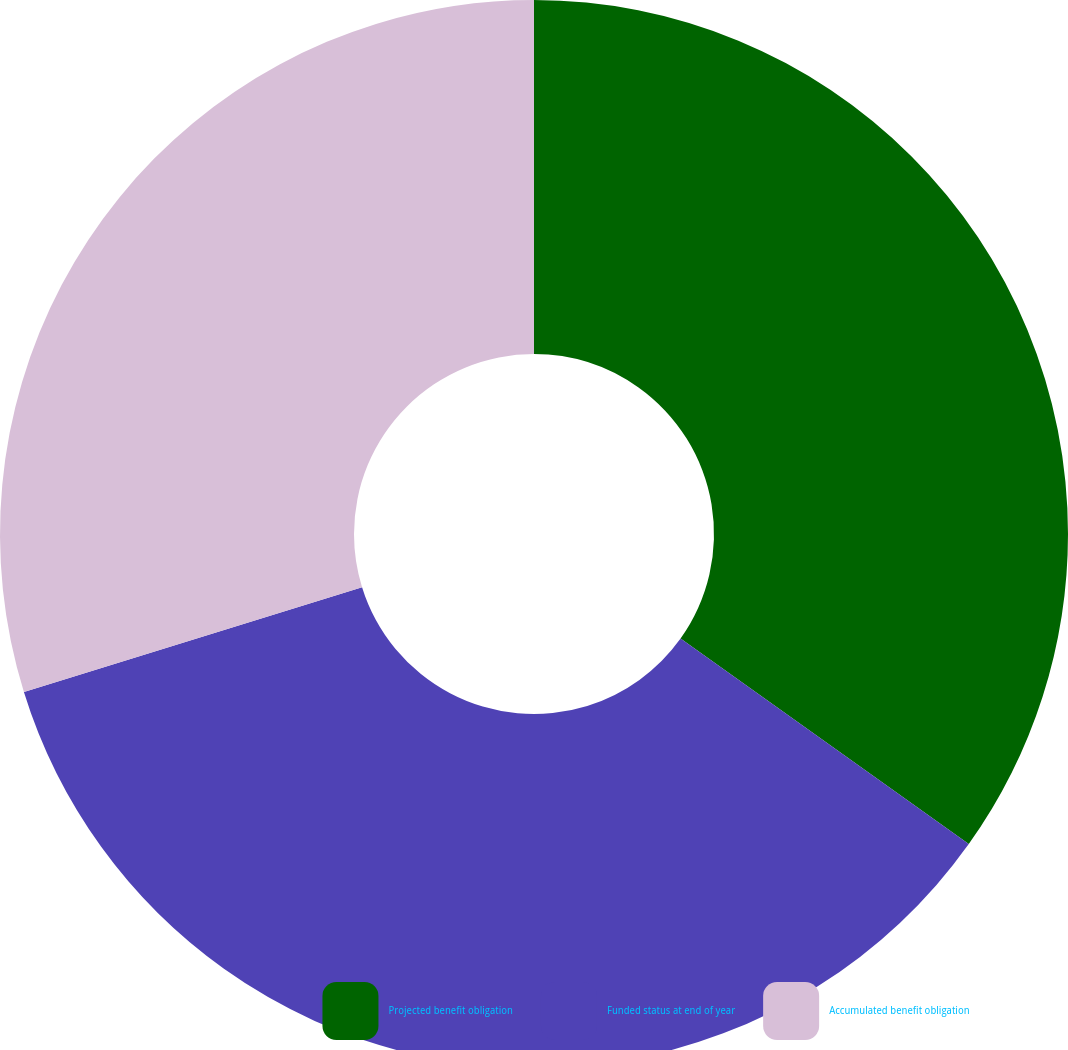Convert chart. <chart><loc_0><loc_0><loc_500><loc_500><pie_chart><fcel>Projected benefit obligation<fcel>Funded status at end of year<fcel>Accumulated benefit obligation<nl><fcel>34.86%<fcel>35.36%<fcel>29.78%<nl></chart> 